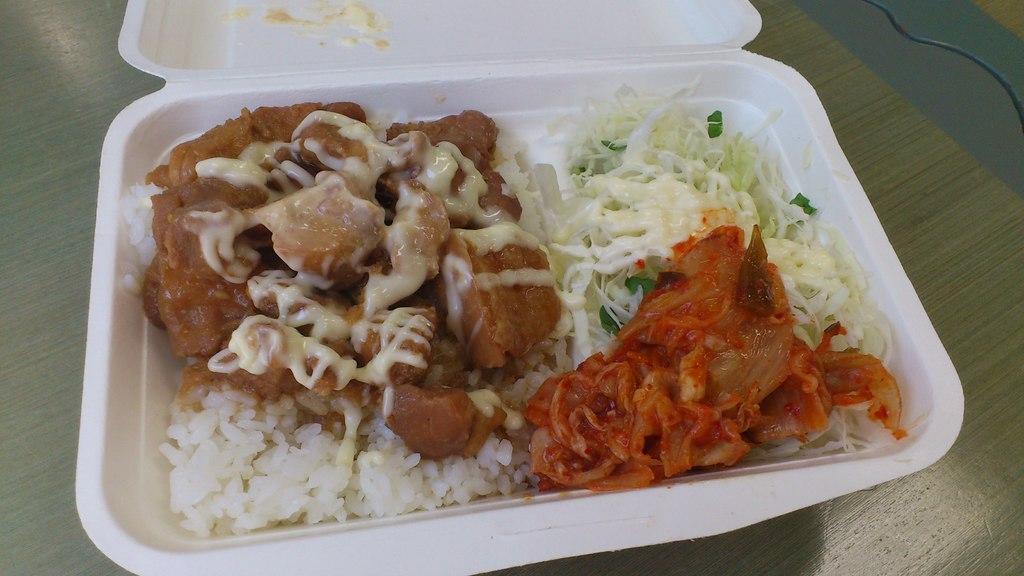What object is visible in the image that might be used for carrying food? There is a lunch box in the image that might be used for carrying food. What color is the lunch box? The lunch box is white. What is inside the lunch box? There is food in the lunch box. Where is the lunch box located in the image? The lunch box is on a table. Is there a kettle boiling water on the table next to the lunch box? There is no kettle present in the image; only the lunch box is visible on the table. 